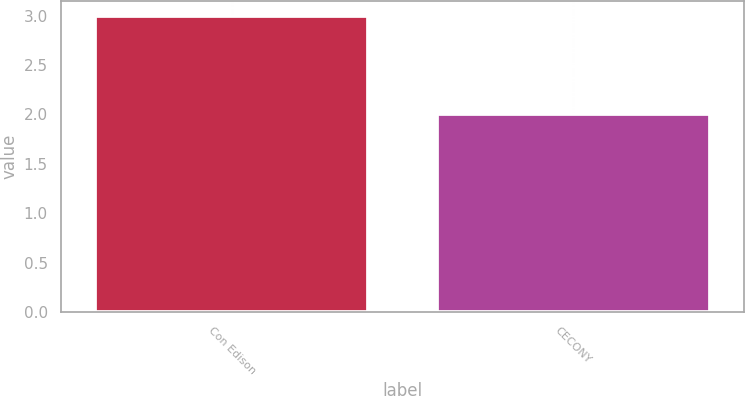<chart> <loc_0><loc_0><loc_500><loc_500><bar_chart><fcel>Con Edison<fcel>CECONY<nl><fcel>3<fcel>2<nl></chart> 